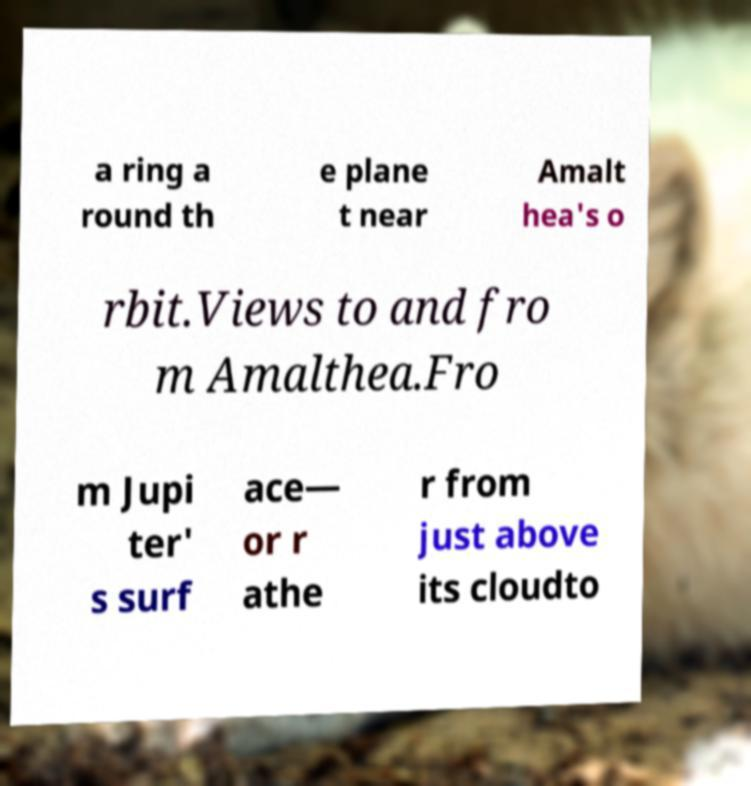What messages or text are displayed in this image? I need them in a readable, typed format. a ring a round th e plane t near Amalt hea's o rbit.Views to and fro m Amalthea.Fro m Jupi ter' s surf ace— or r athe r from just above its cloudto 